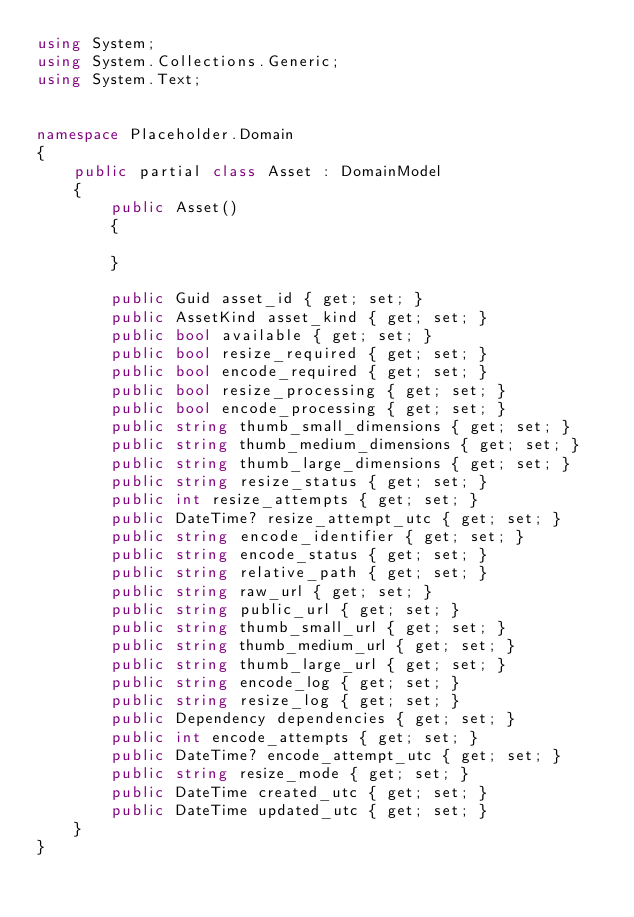<code> <loc_0><loc_0><loc_500><loc_500><_C#_>using System;
using System.Collections.Generic;
using System.Text;


namespace Placeholder.Domain
{
    public partial class Asset : DomainModel
    {	
        public Asset()
        {
				
        }
    
        public Guid asset_id { get; set; }
        public AssetKind asset_kind { get; set; }
        public bool available { get; set; }
        public bool resize_required { get; set; }
        public bool encode_required { get; set; }
        public bool resize_processing { get; set; }
        public bool encode_processing { get; set; }
        public string thumb_small_dimensions { get; set; }
        public string thumb_medium_dimensions { get; set; }
        public string thumb_large_dimensions { get; set; }
        public string resize_status { get; set; }
        public int resize_attempts { get; set; }
        public DateTime? resize_attempt_utc { get; set; }
        public string encode_identifier { get; set; }
        public string encode_status { get; set; }
        public string relative_path { get; set; }
        public string raw_url { get; set; }
        public string public_url { get; set; }
        public string thumb_small_url { get; set; }
        public string thumb_medium_url { get; set; }
        public string thumb_large_url { get; set; }
        public string encode_log { get; set; }
        public string resize_log { get; set; }
        public Dependency dependencies { get; set; }
        public int encode_attempts { get; set; }
        public DateTime? encode_attempt_utc { get; set; }
        public string resize_mode { get; set; }
        public DateTime created_utc { get; set; }
        public DateTime updated_utc { get; set; }
	}
}

</code> 